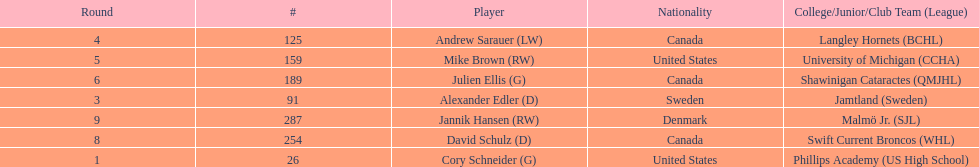What is the name of the last player on this chart? Jannik Hansen (RW). 